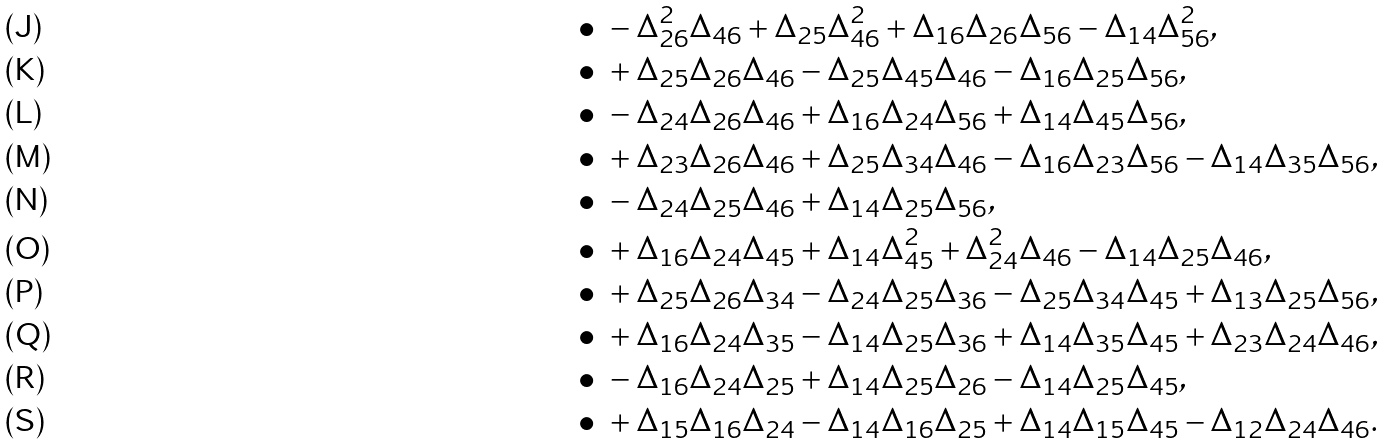<formula> <loc_0><loc_0><loc_500><loc_500>\bullet \ & - \Delta _ { 2 6 } ^ { 2 } \Delta _ { 4 6 } + \Delta _ { 2 5 } \Delta _ { 4 6 } ^ { 2 } + \Delta _ { 1 6 } \Delta _ { 2 6 } \Delta _ { 5 6 } - \Delta _ { 1 4 } \Delta _ { 5 6 } ^ { 2 } , \\ \bullet \ & + \Delta _ { 2 5 } \Delta _ { 2 6 } \Delta _ { 4 6 } - \Delta _ { 2 5 } \Delta _ { 4 5 } \Delta _ { 4 6 } - \Delta _ { 1 6 } \Delta _ { 2 5 } \Delta _ { 5 6 } , \\ \bullet \ & - \Delta _ { 2 4 } \Delta _ { 2 6 } \Delta _ { 4 6 } + \Delta _ { 1 6 } \Delta _ { 2 4 } \Delta _ { 5 6 } + \Delta _ { 1 4 } \Delta _ { 4 5 } \Delta _ { 5 6 } , \\ \bullet \ & + \Delta _ { 2 3 } \Delta _ { 2 6 } \Delta _ { 4 6 } + \Delta _ { 2 5 } \Delta _ { 3 4 } \Delta _ { 4 6 } - \Delta _ { 1 6 } \Delta _ { 2 3 } \Delta _ { 5 6 } - \Delta _ { 1 4 } \Delta _ { 3 5 } \Delta _ { 5 6 } , \\ \bullet \ & - \Delta _ { 2 4 } \Delta _ { 2 5 } \Delta _ { 4 6 } + \Delta _ { 1 4 } \Delta _ { 2 5 } \Delta _ { 5 6 } , \\ \bullet \ & + \Delta _ { 1 6 } \Delta _ { 2 4 } \Delta _ { 4 5 } + \Delta _ { 1 4 } \Delta _ { 4 5 } ^ { 2 } + \Delta _ { 2 4 } ^ { 2 } \Delta _ { 4 6 } - \Delta _ { 1 4 } \Delta _ { 2 5 } \Delta _ { 4 6 } , \\ \bullet \ & + \Delta _ { 2 5 } \Delta _ { 2 6 } \Delta _ { 3 4 } - \Delta _ { 2 4 } \Delta _ { 2 5 } \Delta _ { 3 6 } - \Delta _ { 2 5 } \Delta _ { 3 4 } \Delta _ { 4 5 } + \Delta _ { 1 3 } \Delta _ { 2 5 } \Delta _ { 5 6 } , \\ \bullet \ & + \Delta _ { 1 6 } \Delta _ { 2 4 } \Delta _ { 3 5 } - \Delta _ { 1 4 } \Delta _ { 2 5 } \Delta _ { 3 6 } + \Delta _ { 1 4 } \Delta _ { 3 5 } \Delta _ { 4 5 } + \Delta _ { 2 3 } \Delta _ { 2 4 } \Delta _ { 4 6 } , \\ \bullet \ & - \Delta _ { 1 6 } \Delta _ { 2 4 } \Delta _ { 2 5 } + \Delta _ { 1 4 } \Delta _ { 2 5 } \Delta _ { 2 6 } - \Delta _ { 1 4 } \Delta _ { 2 5 } \Delta _ { 4 5 } , \\ \bullet \ & + \Delta _ { 1 5 } \Delta _ { 1 6 } \Delta _ { 2 4 } - \Delta _ { 1 4 } \Delta _ { 1 6 } \Delta _ { 2 5 } + \Delta _ { 1 4 } \Delta _ { 1 5 } \Delta _ { 4 5 } - \Delta _ { 1 2 } \Delta _ { 2 4 } \Delta _ { 4 6 } .</formula> 